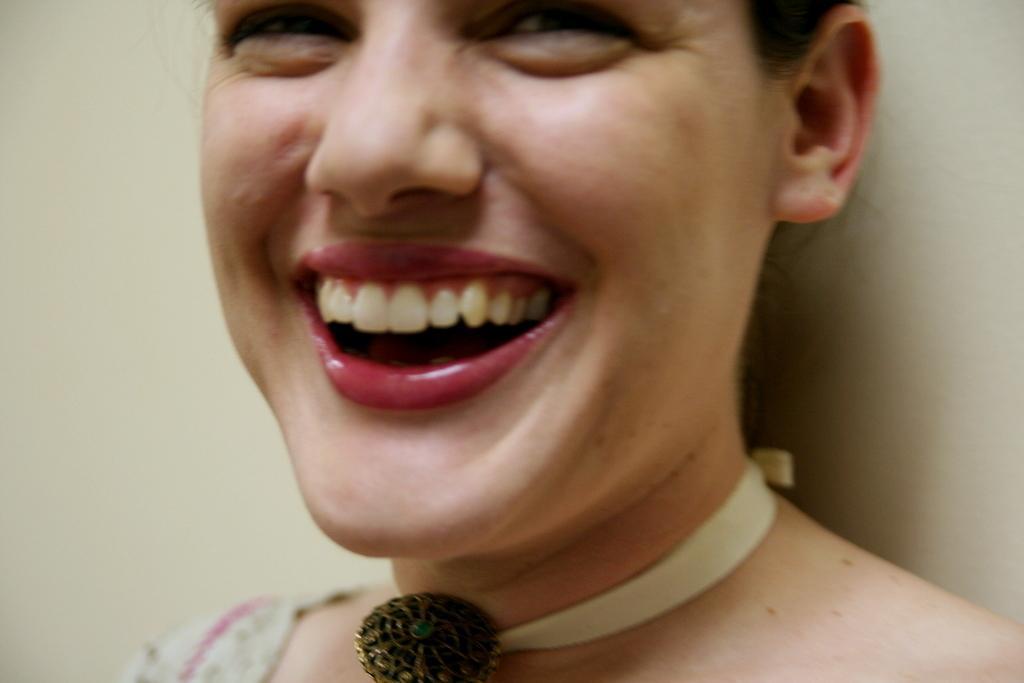Can you describe this image briefly? In this picture there is a woman smiling, behind her we can see wall. 